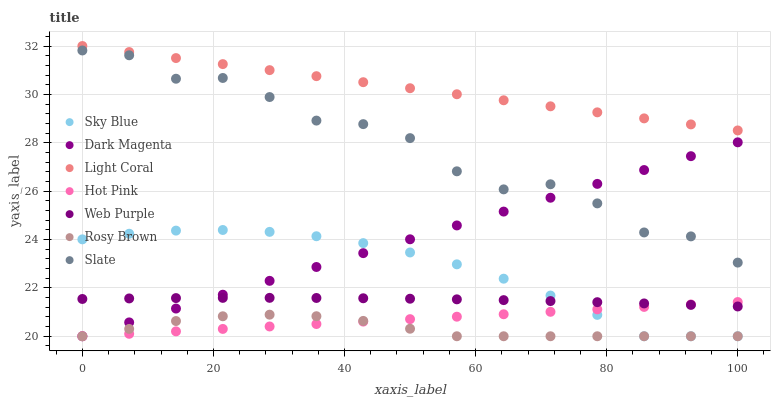Does Rosy Brown have the minimum area under the curve?
Answer yes or no. Yes. Does Light Coral have the maximum area under the curve?
Answer yes or no. Yes. Does Dark Magenta have the minimum area under the curve?
Answer yes or no. No. Does Dark Magenta have the maximum area under the curve?
Answer yes or no. No. Is Hot Pink the smoothest?
Answer yes or no. Yes. Is Slate the roughest?
Answer yes or no. Yes. Is Dark Magenta the smoothest?
Answer yes or no. No. Is Dark Magenta the roughest?
Answer yes or no. No. Does Rosy Brown have the lowest value?
Answer yes or no. Yes. Does Slate have the lowest value?
Answer yes or no. No. Does Light Coral have the highest value?
Answer yes or no. Yes. Does Dark Magenta have the highest value?
Answer yes or no. No. Is Web Purple less than Light Coral?
Answer yes or no. Yes. Is Light Coral greater than Sky Blue?
Answer yes or no. Yes. Does Dark Magenta intersect Hot Pink?
Answer yes or no. Yes. Is Dark Magenta less than Hot Pink?
Answer yes or no. No. Is Dark Magenta greater than Hot Pink?
Answer yes or no. No. Does Web Purple intersect Light Coral?
Answer yes or no. No. 